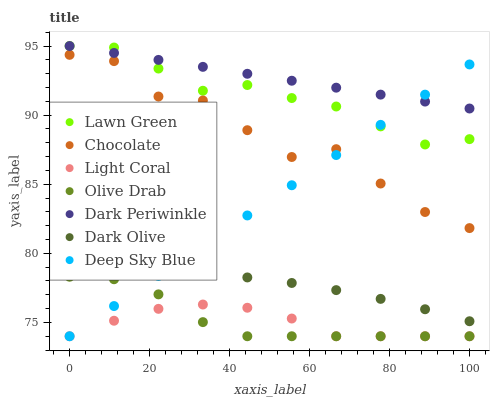Does Light Coral have the minimum area under the curve?
Answer yes or no. Yes. Does Dark Periwinkle have the maximum area under the curve?
Answer yes or no. Yes. Does Dark Olive have the minimum area under the curve?
Answer yes or no. No. Does Dark Olive have the maximum area under the curve?
Answer yes or no. No. Is Dark Periwinkle the smoothest?
Answer yes or no. Yes. Is Chocolate the roughest?
Answer yes or no. Yes. Is Dark Olive the smoothest?
Answer yes or no. No. Is Dark Olive the roughest?
Answer yes or no. No. Does Light Coral have the lowest value?
Answer yes or no. Yes. Does Dark Olive have the lowest value?
Answer yes or no. No. Does Dark Periwinkle have the highest value?
Answer yes or no. Yes. Does Dark Olive have the highest value?
Answer yes or no. No. Is Dark Olive less than Dark Periwinkle?
Answer yes or no. Yes. Is Lawn Green greater than Light Coral?
Answer yes or no. Yes. Does Lawn Green intersect Deep Sky Blue?
Answer yes or no. Yes. Is Lawn Green less than Deep Sky Blue?
Answer yes or no. No. Is Lawn Green greater than Deep Sky Blue?
Answer yes or no. No. Does Dark Olive intersect Dark Periwinkle?
Answer yes or no. No. 